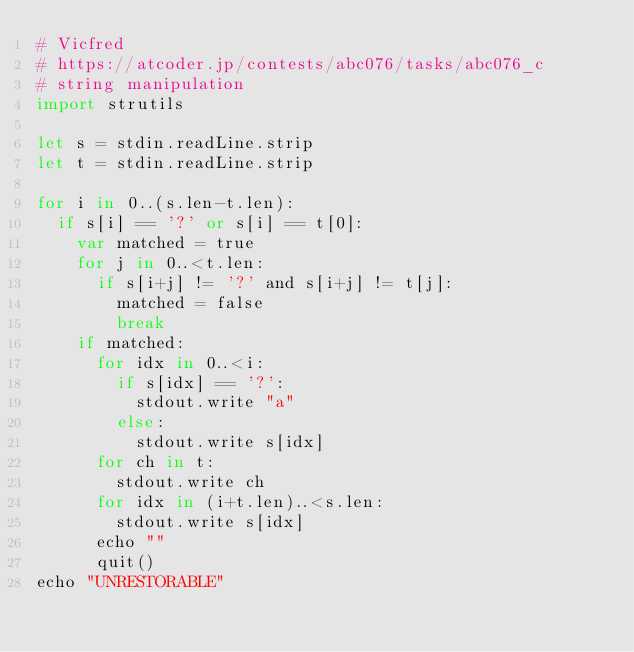Convert code to text. <code><loc_0><loc_0><loc_500><loc_500><_Nim_># Vicfred
# https://atcoder.jp/contests/abc076/tasks/abc076_c
# string manipulation
import strutils

let s = stdin.readLine.strip
let t = stdin.readLine.strip

for i in 0..(s.len-t.len):
  if s[i] == '?' or s[i] == t[0]:
    var matched = true
    for j in 0..<t.len:
      if s[i+j] != '?' and s[i+j] != t[j]:
        matched = false
        break
    if matched:
      for idx in 0..<i:
        if s[idx] == '?':
          stdout.write "a"
        else:
          stdout.write s[idx]
      for ch in t:
        stdout.write ch
      for idx in (i+t.len)..<s.len:
        stdout.write s[idx]
      echo ""
      quit()
echo "UNRESTORABLE"
</code> 